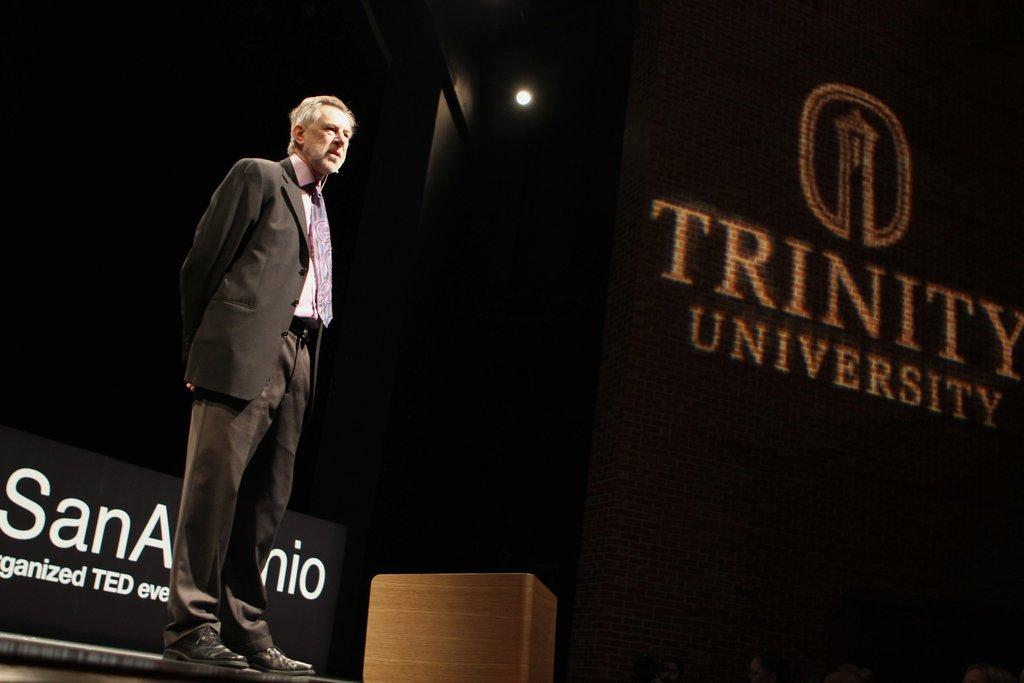Who or what is present in the image? There is a person in the image. What can be seen on the floor in the image? There is an object on the floor. What type of signage is visible in the image? There are advertising boards in the image. What information is displayed on the advertising boards? There is text on the advertising boards. Can you see any clouds in the image? There is no mention of clouds in the provided facts, and therefore we cannot determine if any are present in the image. 